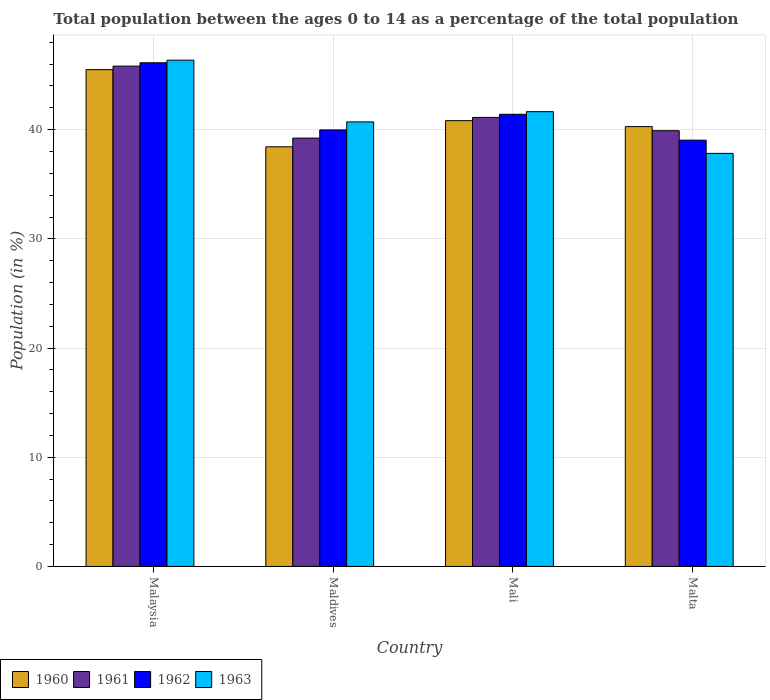How many different coloured bars are there?
Provide a succinct answer. 4. How many bars are there on the 4th tick from the left?
Make the answer very short. 4. What is the label of the 1st group of bars from the left?
Provide a short and direct response. Malaysia. In how many cases, is the number of bars for a given country not equal to the number of legend labels?
Give a very brief answer. 0. What is the percentage of the population ages 0 to 14 in 1963 in Maldives?
Your answer should be very brief. 40.71. Across all countries, what is the maximum percentage of the population ages 0 to 14 in 1961?
Make the answer very short. 45.82. Across all countries, what is the minimum percentage of the population ages 0 to 14 in 1961?
Provide a succinct answer. 39.23. In which country was the percentage of the population ages 0 to 14 in 1962 maximum?
Provide a succinct answer. Malaysia. In which country was the percentage of the population ages 0 to 14 in 1960 minimum?
Your answer should be very brief. Maldives. What is the total percentage of the population ages 0 to 14 in 1962 in the graph?
Your answer should be very brief. 166.55. What is the difference between the percentage of the population ages 0 to 14 in 1961 in Mali and that in Malta?
Provide a succinct answer. 1.22. What is the difference between the percentage of the population ages 0 to 14 in 1962 in Malaysia and the percentage of the population ages 0 to 14 in 1963 in Mali?
Give a very brief answer. 4.48. What is the average percentage of the population ages 0 to 14 in 1961 per country?
Keep it short and to the point. 41.52. What is the difference between the percentage of the population ages 0 to 14 of/in 1960 and percentage of the population ages 0 to 14 of/in 1963 in Maldives?
Your answer should be compact. -2.28. In how many countries, is the percentage of the population ages 0 to 14 in 1963 greater than 38?
Provide a succinct answer. 3. What is the ratio of the percentage of the population ages 0 to 14 in 1963 in Mali to that in Malta?
Offer a very short reply. 1.1. Is the difference between the percentage of the population ages 0 to 14 in 1960 in Maldives and Mali greater than the difference between the percentage of the population ages 0 to 14 in 1963 in Maldives and Mali?
Make the answer very short. No. What is the difference between the highest and the second highest percentage of the population ages 0 to 14 in 1962?
Offer a very short reply. -4.72. What is the difference between the highest and the lowest percentage of the population ages 0 to 14 in 1963?
Offer a terse response. 8.54. In how many countries, is the percentage of the population ages 0 to 14 in 1961 greater than the average percentage of the population ages 0 to 14 in 1961 taken over all countries?
Make the answer very short. 1. Is the sum of the percentage of the population ages 0 to 14 in 1962 in Maldives and Mali greater than the maximum percentage of the population ages 0 to 14 in 1960 across all countries?
Your answer should be compact. Yes. Is it the case that in every country, the sum of the percentage of the population ages 0 to 14 in 1962 and percentage of the population ages 0 to 14 in 1961 is greater than the sum of percentage of the population ages 0 to 14 in 1960 and percentage of the population ages 0 to 14 in 1963?
Keep it short and to the point. No. What does the 4th bar from the left in Malaysia represents?
Provide a succinct answer. 1963. Is it the case that in every country, the sum of the percentage of the population ages 0 to 14 in 1962 and percentage of the population ages 0 to 14 in 1963 is greater than the percentage of the population ages 0 to 14 in 1961?
Ensure brevity in your answer.  Yes. Are all the bars in the graph horizontal?
Provide a short and direct response. No. What is the difference between two consecutive major ticks on the Y-axis?
Your response must be concise. 10. Are the values on the major ticks of Y-axis written in scientific E-notation?
Ensure brevity in your answer.  No. Where does the legend appear in the graph?
Provide a succinct answer. Bottom left. What is the title of the graph?
Your answer should be very brief. Total population between the ages 0 to 14 as a percentage of the total population. What is the label or title of the X-axis?
Make the answer very short. Country. What is the label or title of the Y-axis?
Give a very brief answer. Population (in %). What is the Population (in %) of 1960 in Malaysia?
Offer a very short reply. 45.5. What is the Population (in %) in 1961 in Malaysia?
Your answer should be very brief. 45.82. What is the Population (in %) in 1962 in Malaysia?
Your answer should be very brief. 46.13. What is the Population (in %) of 1963 in Malaysia?
Keep it short and to the point. 46.36. What is the Population (in %) of 1960 in Maldives?
Offer a very short reply. 38.43. What is the Population (in %) of 1961 in Maldives?
Offer a very short reply. 39.23. What is the Population (in %) in 1962 in Maldives?
Give a very brief answer. 39.98. What is the Population (in %) of 1963 in Maldives?
Ensure brevity in your answer.  40.71. What is the Population (in %) of 1960 in Mali?
Your response must be concise. 40.82. What is the Population (in %) in 1961 in Mali?
Your answer should be very brief. 41.12. What is the Population (in %) in 1962 in Mali?
Offer a terse response. 41.41. What is the Population (in %) in 1963 in Mali?
Your response must be concise. 41.65. What is the Population (in %) of 1960 in Malta?
Give a very brief answer. 40.28. What is the Population (in %) of 1961 in Malta?
Offer a very short reply. 39.91. What is the Population (in %) in 1962 in Malta?
Make the answer very short. 39.04. What is the Population (in %) in 1963 in Malta?
Keep it short and to the point. 37.83. Across all countries, what is the maximum Population (in %) in 1960?
Provide a short and direct response. 45.5. Across all countries, what is the maximum Population (in %) of 1961?
Your response must be concise. 45.82. Across all countries, what is the maximum Population (in %) in 1962?
Offer a very short reply. 46.13. Across all countries, what is the maximum Population (in %) in 1963?
Your response must be concise. 46.36. Across all countries, what is the minimum Population (in %) in 1960?
Your response must be concise. 38.43. Across all countries, what is the minimum Population (in %) in 1961?
Your answer should be compact. 39.23. Across all countries, what is the minimum Population (in %) of 1962?
Provide a succinct answer. 39.04. Across all countries, what is the minimum Population (in %) of 1963?
Provide a succinct answer. 37.83. What is the total Population (in %) in 1960 in the graph?
Provide a succinct answer. 165.04. What is the total Population (in %) of 1961 in the graph?
Give a very brief answer. 166.08. What is the total Population (in %) in 1962 in the graph?
Your answer should be very brief. 166.55. What is the total Population (in %) of 1963 in the graph?
Give a very brief answer. 166.55. What is the difference between the Population (in %) of 1960 in Malaysia and that in Maldives?
Provide a succinct answer. 7.07. What is the difference between the Population (in %) in 1961 in Malaysia and that in Maldives?
Provide a succinct answer. 6.59. What is the difference between the Population (in %) of 1962 in Malaysia and that in Maldives?
Keep it short and to the point. 6.15. What is the difference between the Population (in %) in 1963 in Malaysia and that in Maldives?
Your response must be concise. 5.65. What is the difference between the Population (in %) in 1960 in Malaysia and that in Mali?
Make the answer very short. 4.68. What is the difference between the Population (in %) of 1961 in Malaysia and that in Mali?
Give a very brief answer. 4.7. What is the difference between the Population (in %) of 1962 in Malaysia and that in Mali?
Your answer should be compact. 4.72. What is the difference between the Population (in %) in 1963 in Malaysia and that in Mali?
Your answer should be very brief. 4.71. What is the difference between the Population (in %) of 1960 in Malaysia and that in Malta?
Provide a succinct answer. 5.22. What is the difference between the Population (in %) of 1961 in Malaysia and that in Malta?
Keep it short and to the point. 5.91. What is the difference between the Population (in %) of 1962 in Malaysia and that in Malta?
Make the answer very short. 7.09. What is the difference between the Population (in %) in 1963 in Malaysia and that in Malta?
Provide a short and direct response. 8.54. What is the difference between the Population (in %) of 1960 in Maldives and that in Mali?
Keep it short and to the point. -2.39. What is the difference between the Population (in %) of 1961 in Maldives and that in Mali?
Your response must be concise. -1.89. What is the difference between the Population (in %) of 1962 in Maldives and that in Mali?
Provide a succinct answer. -1.43. What is the difference between the Population (in %) in 1963 in Maldives and that in Mali?
Provide a short and direct response. -0.94. What is the difference between the Population (in %) of 1960 in Maldives and that in Malta?
Offer a terse response. -1.85. What is the difference between the Population (in %) in 1961 in Maldives and that in Malta?
Make the answer very short. -0.68. What is the difference between the Population (in %) in 1962 in Maldives and that in Malta?
Your answer should be very brief. 0.94. What is the difference between the Population (in %) of 1963 in Maldives and that in Malta?
Provide a short and direct response. 2.88. What is the difference between the Population (in %) of 1960 in Mali and that in Malta?
Provide a succinct answer. 0.54. What is the difference between the Population (in %) in 1961 in Mali and that in Malta?
Give a very brief answer. 1.22. What is the difference between the Population (in %) in 1962 in Mali and that in Malta?
Your answer should be very brief. 2.37. What is the difference between the Population (in %) of 1963 in Mali and that in Malta?
Your answer should be compact. 3.82. What is the difference between the Population (in %) of 1960 in Malaysia and the Population (in %) of 1961 in Maldives?
Keep it short and to the point. 6.27. What is the difference between the Population (in %) in 1960 in Malaysia and the Population (in %) in 1962 in Maldives?
Provide a short and direct response. 5.52. What is the difference between the Population (in %) in 1960 in Malaysia and the Population (in %) in 1963 in Maldives?
Ensure brevity in your answer.  4.79. What is the difference between the Population (in %) in 1961 in Malaysia and the Population (in %) in 1962 in Maldives?
Keep it short and to the point. 5.84. What is the difference between the Population (in %) in 1961 in Malaysia and the Population (in %) in 1963 in Maldives?
Keep it short and to the point. 5.11. What is the difference between the Population (in %) of 1962 in Malaysia and the Population (in %) of 1963 in Maldives?
Offer a very short reply. 5.41. What is the difference between the Population (in %) of 1960 in Malaysia and the Population (in %) of 1961 in Mali?
Ensure brevity in your answer.  4.38. What is the difference between the Population (in %) of 1960 in Malaysia and the Population (in %) of 1962 in Mali?
Your answer should be compact. 4.09. What is the difference between the Population (in %) of 1960 in Malaysia and the Population (in %) of 1963 in Mali?
Your answer should be compact. 3.85. What is the difference between the Population (in %) in 1961 in Malaysia and the Population (in %) in 1962 in Mali?
Make the answer very short. 4.41. What is the difference between the Population (in %) in 1961 in Malaysia and the Population (in %) in 1963 in Mali?
Make the answer very short. 4.17. What is the difference between the Population (in %) of 1962 in Malaysia and the Population (in %) of 1963 in Mali?
Your response must be concise. 4.48. What is the difference between the Population (in %) in 1960 in Malaysia and the Population (in %) in 1961 in Malta?
Your response must be concise. 5.59. What is the difference between the Population (in %) in 1960 in Malaysia and the Population (in %) in 1962 in Malta?
Provide a short and direct response. 6.46. What is the difference between the Population (in %) of 1960 in Malaysia and the Population (in %) of 1963 in Malta?
Your answer should be very brief. 7.67. What is the difference between the Population (in %) in 1961 in Malaysia and the Population (in %) in 1962 in Malta?
Make the answer very short. 6.78. What is the difference between the Population (in %) in 1961 in Malaysia and the Population (in %) in 1963 in Malta?
Offer a very short reply. 7.99. What is the difference between the Population (in %) of 1962 in Malaysia and the Population (in %) of 1963 in Malta?
Ensure brevity in your answer.  8.3. What is the difference between the Population (in %) of 1960 in Maldives and the Population (in %) of 1961 in Mali?
Your answer should be compact. -2.69. What is the difference between the Population (in %) of 1960 in Maldives and the Population (in %) of 1962 in Mali?
Offer a terse response. -2.98. What is the difference between the Population (in %) in 1960 in Maldives and the Population (in %) in 1963 in Mali?
Provide a short and direct response. -3.22. What is the difference between the Population (in %) of 1961 in Maldives and the Population (in %) of 1962 in Mali?
Your response must be concise. -2.18. What is the difference between the Population (in %) of 1961 in Maldives and the Population (in %) of 1963 in Mali?
Your answer should be very brief. -2.42. What is the difference between the Population (in %) in 1962 in Maldives and the Population (in %) in 1963 in Mali?
Offer a very short reply. -1.67. What is the difference between the Population (in %) in 1960 in Maldives and the Population (in %) in 1961 in Malta?
Your answer should be compact. -1.48. What is the difference between the Population (in %) of 1960 in Maldives and the Population (in %) of 1962 in Malta?
Your answer should be very brief. -0.61. What is the difference between the Population (in %) in 1960 in Maldives and the Population (in %) in 1963 in Malta?
Make the answer very short. 0.6. What is the difference between the Population (in %) of 1961 in Maldives and the Population (in %) of 1962 in Malta?
Give a very brief answer. 0.19. What is the difference between the Population (in %) in 1961 in Maldives and the Population (in %) in 1963 in Malta?
Your response must be concise. 1.4. What is the difference between the Population (in %) of 1962 in Maldives and the Population (in %) of 1963 in Malta?
Your answer should be compact. 2.15. What is the difference between the Population (in %) of 1960 in Mali and the Population (in %) of 1961 in Malta?
Keep it short and to the point. 0.92. What is the difference between the Population (in %) of 1960 in Mali and the Population (in %) of 1962 in Malta?
Give a very brief answer. 1.78. What is the difference between the Population (in %) of 1960 in Mali and the Population (in %) of 1963 in Malta?
Offer a terse response. 3. What is the difference between the Population (in %) of 1961 in Mali and the Population (in %) of 1962 in Malta?
Offer a very short reply. 2.08. What is the difference between the Population (in %) in 1961 in Mali and the Population (in %) in 1963 in Malta?
Your answer should be compact. 3.29. What is the difference between the Population (in %) of 1962 in Mali and the Population (in %) of 1963 in Malta?
Ensure brevity in your answer.  3.58. What is the average Population (in %) of 1960 per country?
Your answer should be very brief. 41.26. What is the average Population (in %) in 1961 per country?
Your answer should be compact. 41.52. What is the average Population (in %) of 1962 per country?
Your response must be concise. 41.64. What is the average Population (in %) in 1963 per country?
Provide a short and direct response. 41.64. What is the difference between the Population (in %) of 1960 and Population (in %) of 1961 in Malaysia?
Provide a short and direct response. -0.32. What is the difference between the Population (in %) of 1960 and Population (in %) of 1962 in Malaysia?
Give a very brief answer. -0.63. What is the difference between the Population (in %) in 1960 and Population (in %) in 1963 in Malaysia?
Make the answer very short. -0.86. What is the difference between the Population (in %) of 1961 and Population (in %) of 1962 in Malaysia?
Make the answer very short. -0.31. What is the difference between the Population (in %) of 1961 and Population (in %) of 1963 in Malaysia?
Offer a very short reply. -0.54. What is the difference between the Population (in %) of 1962 and Population (in %) of 1963 in Malaysia?
Ensure brevity in your answer.  -0.24. What is the difference between the Population (in %) of 1960 and Population (in %) of 1961 in Maldives?
Make the answer very short. -0.8. What is the difference between the Population (in %) in 1960 and Population (in %) in 1962 in Maldives?
Offer a terse response. -1.55. What is the difference between the Population (in %) of 1960 and Population (in %) of 1963 in Maldives?
Your answer should be very brief. -2.28. What is the difference between the Population (in %) in 1961 and Population (in %) in 1962 in Maldives?
Provide a short and direct response. -0.75. What is the difference between the Population (in %) in 1961 and Population (in %) in 1963 in Maldives?
Give a very brief answer. -1.48. What is the difference between the Population (in %) of 1962 and Population (in %) of 1963 in Maldives?
Offer a terse response. -0.73. What is the difference between the Population (in %) of 1960 and Population (in %) of 1961 in Mali?
Keep it short and to the point. -0.3. What is the difference between the Population (in %) in 1960 and Population (in %) in 1962 in Mali?
Give a very brief answer. -0.58. What is the difference between the Population (in %) of 1960 and Population (in %) of 1963 in Mali?
Your response must be concise. -0.82. What is the difference between the Population (in %) of 1961 and Population (in %) of 1962 in Mali?
Give a very brief answer. -0.29. What is the difference between the Population (in %) in 1961 and Population (in %) in 1963 in Mali?
Offer a very short reply. -0.53. What is the difference between the Population (in %) of 1962 and Population (in %) of 1963 in Mali?
Keep it short and to the point. -0.24. What is the difference between the Population (in %) in 1960 and Population (in %) in 1961 in Malta?
Keep it short and to the point. 0.37. What is the difference between the Population (in %) of 1960 and Population (in %) of 1962 in Malta?
Offer a very short reply. 1.24. What is the difference between the Population (in %) in 1960 and Population (in %) in 1963 in Malta?
Your response must be concise. 2.45. What is the difference between the Population (in %) of 1961 and Population (in %) of 1962 in Malta?
Your answer should be compact. 0.87. What is the difference between the Population (in %) of 1961 and Population (in %) of 1963 in Malta?
Keep it short and to the point. 2.08. What is the difference between the Population (in %) of 1962 and Population (in %) of 1963 in Malta?
Your answer should be compact. 1.21. What is the ratio of the Population (in %) of 1960 in Malaysia to that in Maldives?
Your answer should be compact. 1.18. What is the ratio of the Population (in %) in 1961 in Malaysia to that in Maldives?
Your response must be concise. 1.17. What is the ratio of the Population (in %) of 1962 in Malaysia to that in Maldives?
Give a very brief answer. 1.15. What is the ratio of the Population (in %) in 1963 in Malaysia to that in Maldives?
Ensure brevity in your answer.  1.14. What is the ratio of the Population (in %) in 1960 in Malaysia to that in Mali?
Offer a very short reply. 1.11. What is the ratio of the Population (in %) of 1961 in Malaysia to that in Mali?
Keep it short and to the point. 1.11. What is the ratio of the Population (in %) of 1962 in Malaysia to that in Mali?
Make the answer very short. 1.11. What is the ratio of the Population (in %) of 1963 in Malaysia to that in Mali?
Make the answer very short. 1.11. What is the ratio of the Population (in %) in 1960 in Malaysia to that in Malta?
Ensure brevity in your answer.  1.13. What is the ratio of the Population (in %) in 1961 in Malaysia to that in Malta?
Provide a succinct answer. 1.15. What is the ratio of the Population (in %) of 1962 in Malaysia to that in Malta?
Give a very brief answer. 1.18. What is the ratio of the Population (in %) of 1963 in Malaysia to that in Malta?
Give a very brief answer. 1.23. What is the ratio of the Population (in %) in 1960 in Maldives to that in Mali?
Offer a terse response. 0.94. What is the ratio of the Population (in %) of 1961 in Maldives to that in Mali?
Your answer should be very brief. 0.95. What is the ratio of the Population (in %) of 1962 in Maldives to that in Mali?
Offer a very short reply. 0.97. What is the ratio of the Population (in %) of 1963 in Maldives to that in Mali?
Offer a terse response. 0.98. What is the ratio of the Population (in %) in 1960 in Maldives to that in Malta?
Provide a succinct answer. 0.95. What is the ratio of the Population (in %) of 1962 in Maldives to that in Malta?
Ensure brevity in your answer.  1.02. What is the ratio of the Population (in %) in 1963 in Maldives to that in Malta?
Provide a succinct answer. 1.08. What is the ratio of the Population (in %) of 1960 in Mali to that in Malta?
Your answer should be compact. 1.01. What is the ratio of the Population (in %) in 1961 in Mali to that in Malta?
Ensure brevity in your answer.  1.03. What is the ratio of the Population (in %) in 1962 in Mali to that in Malta?
Offer a very short reply. 1.06. What is the ratio of the Population (in %) in 1963 in Mali to that in Malta?
Provide a succinct answer. 1.1. What is the difference between the highest and the second highest Population (in %) in 1960?
Your answer should be very brief. 4.68. What is the difference between the highest and the second highest Population (in %) of 1961?
Your answer should be very brief. 4.7. What is the difference between the highest and the second highest Population (in %) of 1962?
Your answer should be very brief. 4.72. What is the difference between the highest and the second highest Population (in %) of 1963?
Your answer should be compact. 4.71. What is the difference between the highest and the lowest Population (in %) of 1960?
Your answer should be very brief. 7.07. What is the difference between the highest and the lowest Population (in %) in 1961?
Provide a short and direct response. 6.59. What is the difference between the highest and the lowest Population (in %) of 1962?
Ensure brevity in your answer.  7.09. What is the difference between the highest and the lowest Population (in %) in 1963?
Keep it short and to the point. 8.54. 